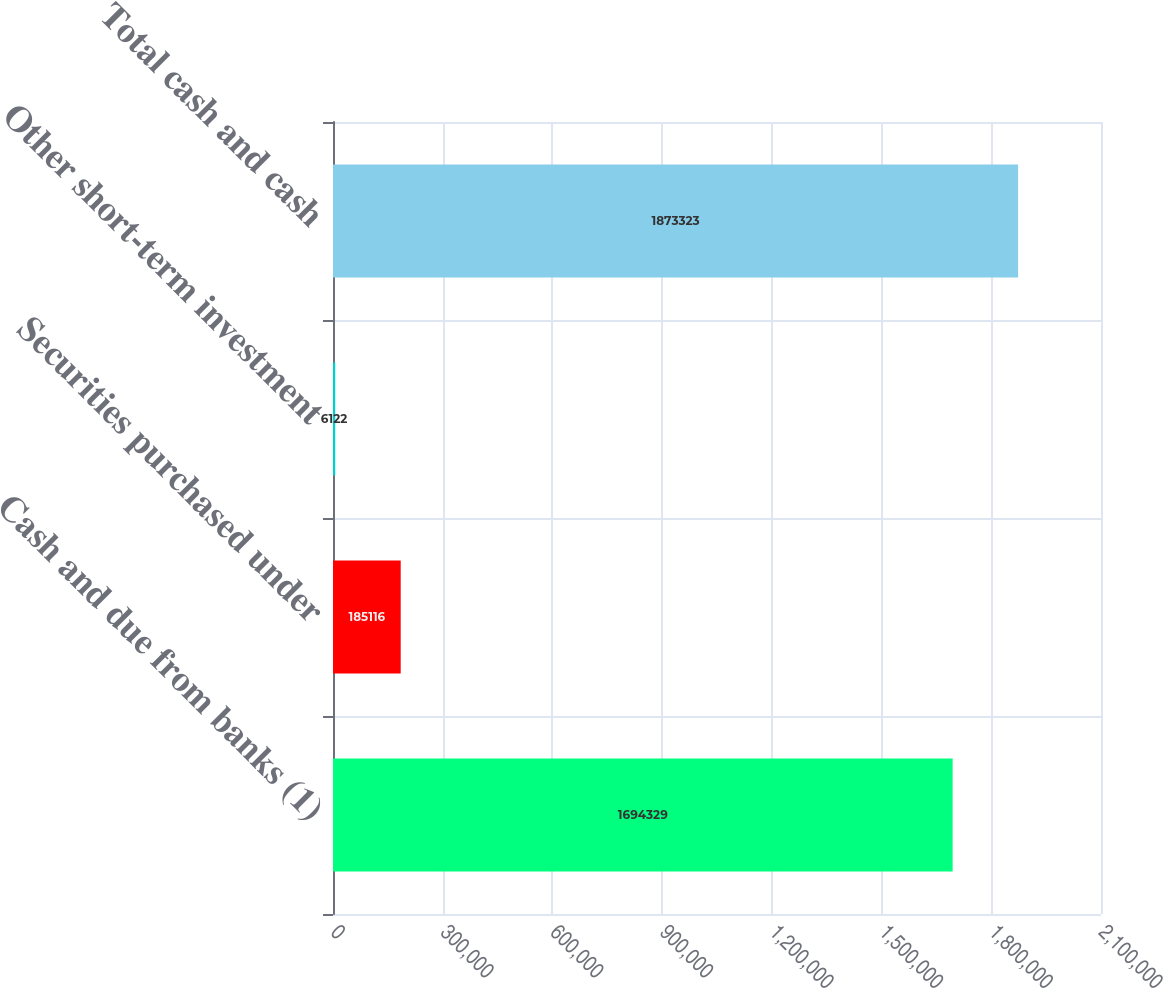Convert chart. <chart><loc_0><loc_0><loc_500><loc_500><bar_chart><fcel>Cash and due from banks (1)<fcel>Securities purchased under<fcel>Other short-term investment<fcel>Total cash and cash<nl><fcel>1.69433e+06<fcel>185116<fcel>6122<fcel>1.87332e+06<nl></chart> 